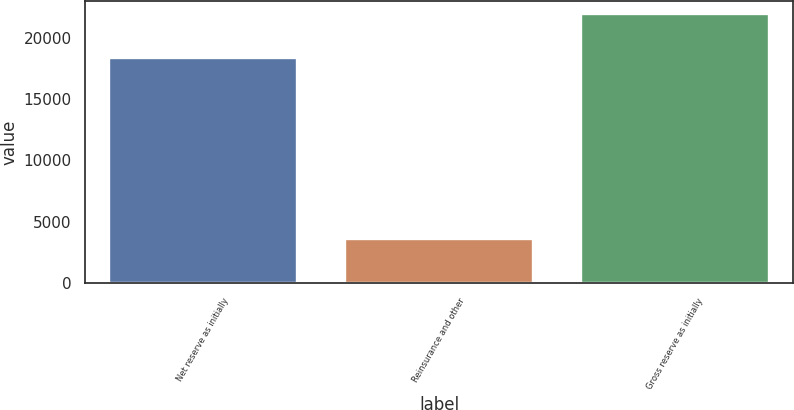Convert chart. <chart><loc_0><loc_0><loc_500><loc_500><bar_chart><fcel>Net reserve as initially<fcel>Reinsurance and other<fcel>Gross reserve as initially<nl><fcel>18347<fcel>3586<fcel>21933<nl></chart> 